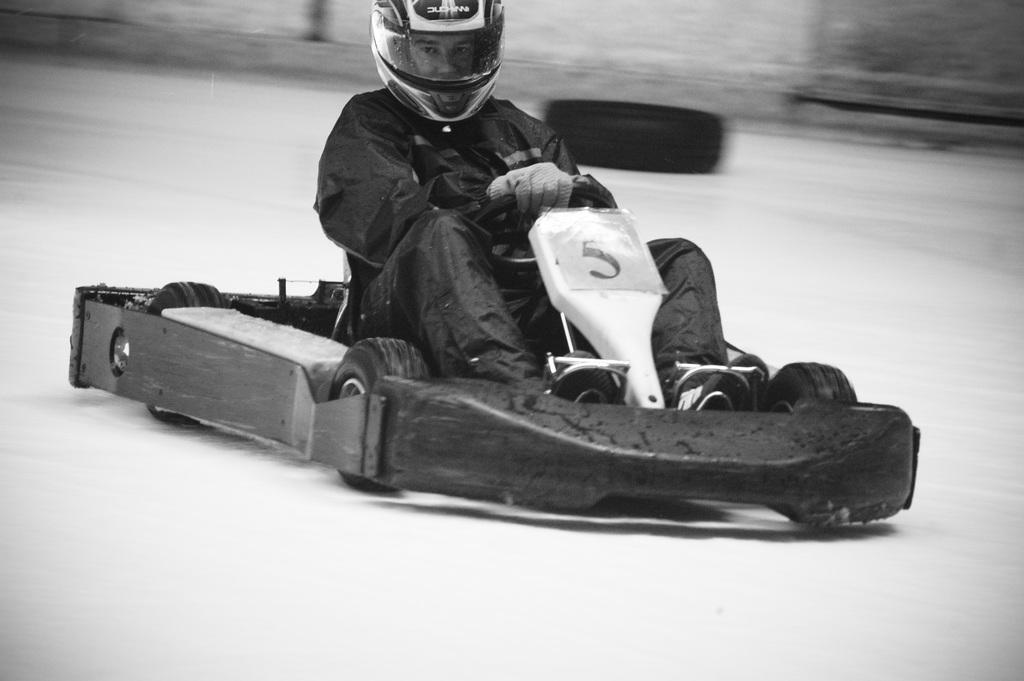What is the color scheme of the image? The image is black and white. What is the person in the image doing? The person is sitting on a go kart car. What can be seen in the background of the image? There is a tire in the background of the image. What type of letters can be seen on the go kart car in the image? There are no letters visible on the go kart car in the image. What kind of flowers are growing near the tire in the background? There are no flowers present in the image; it only features a tire in the background. 